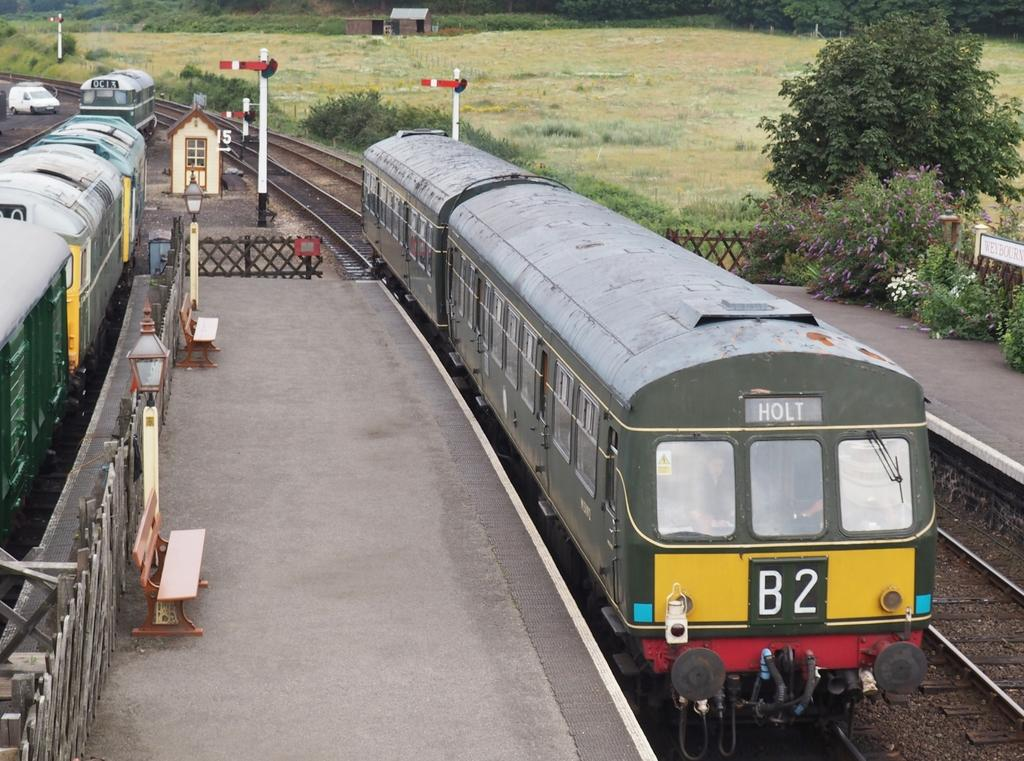Provide a one-sentence caption for the provided image. OC13 is the number of the train on the plate. 